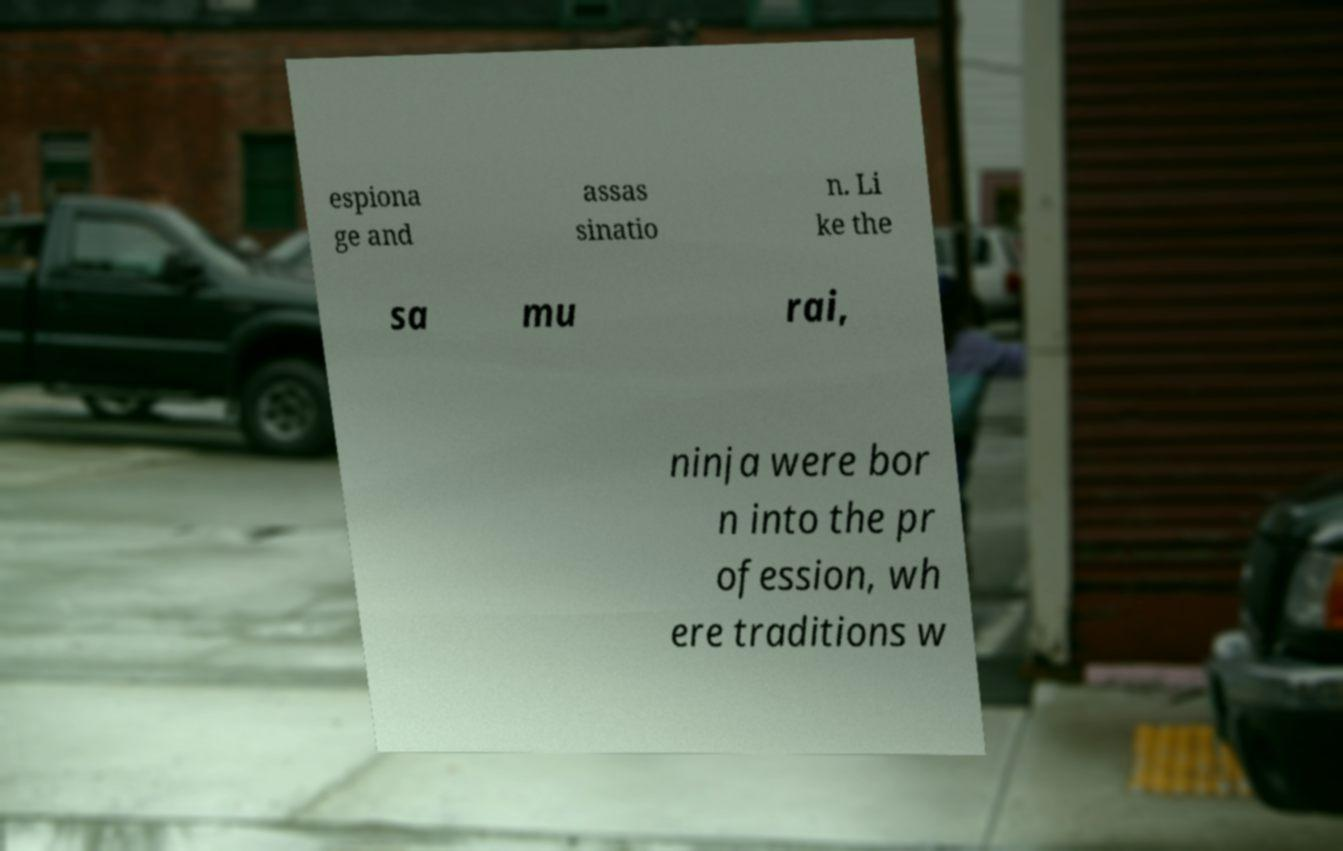Please read and relay the text visible in this image. What does it say? espiona ge and assas sinatio n. Li ke the sa mu rai, ninja were bor n into the pr ofession, wh ere traditions w 